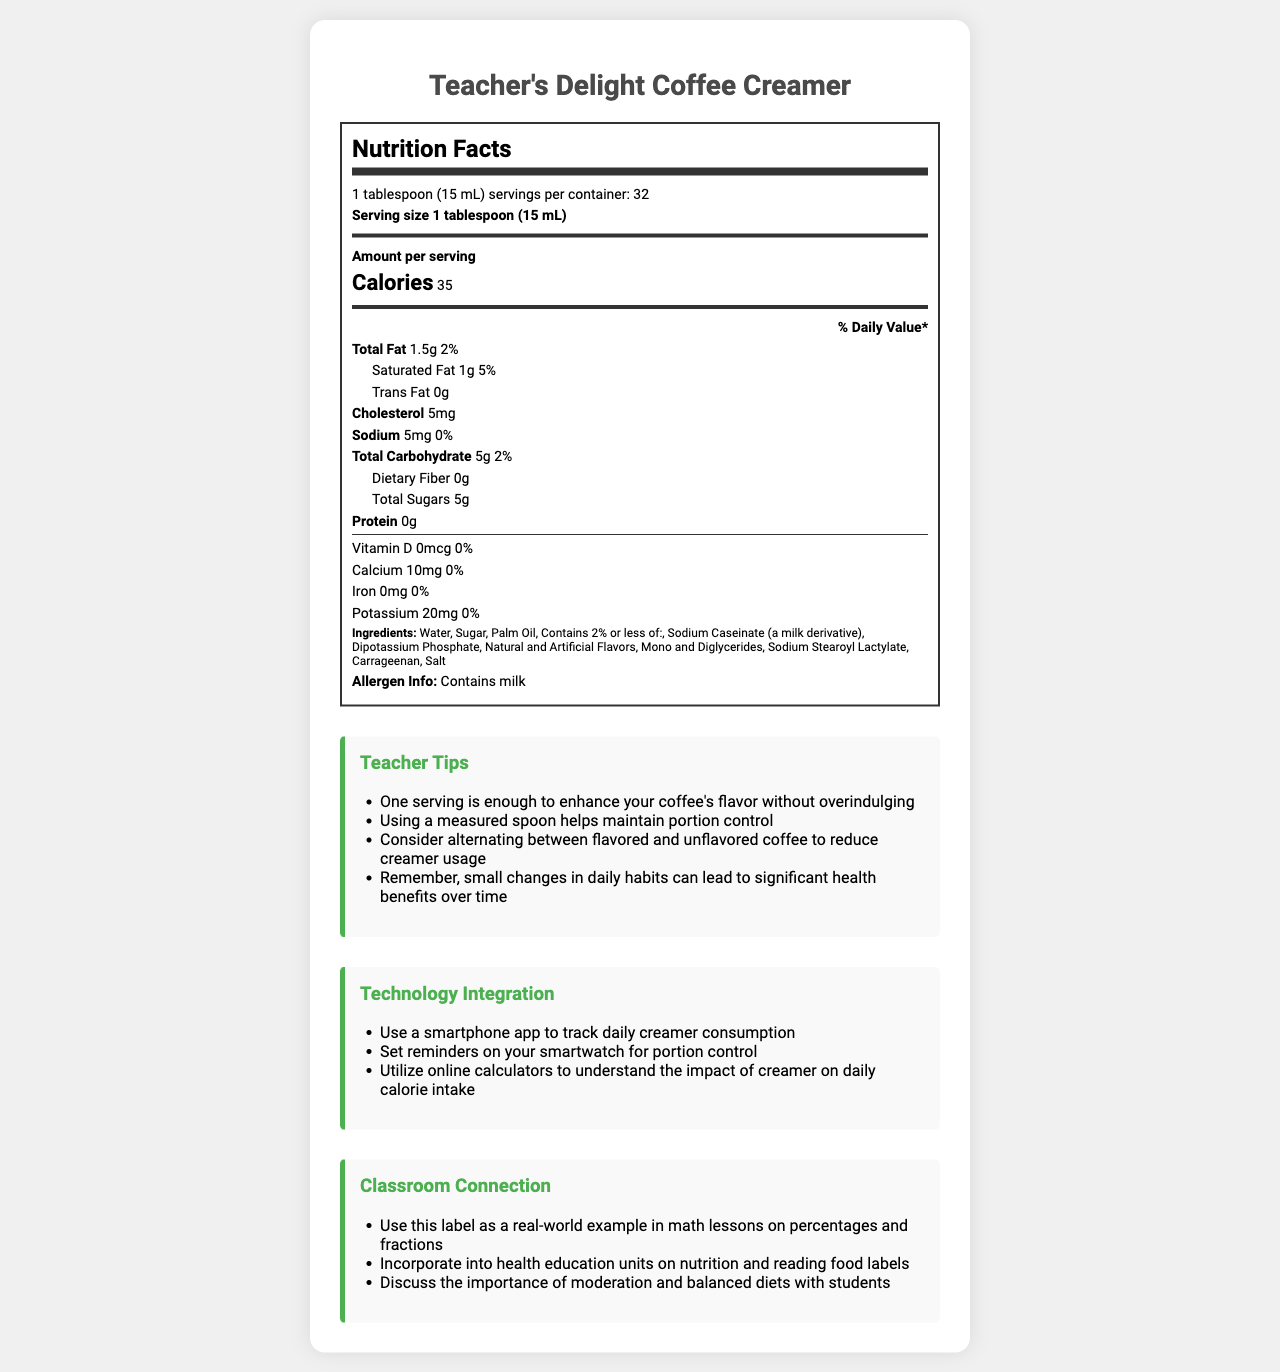what is the serving size? The serving size is clearly stated as "1 tablespoon (15 mL)" at the beginning of the nutrition facts section.
Answer: 1 tablespoon (15 mL) how many calories are in one serving? The document lists the number of calories per serving as "35" right after the serving size information.
Answer: 35 how much total fat does one serving contain? The total fat content per serving is specified as "1.5g" in the nutrition facts.
Answer: 1.5g what percentage of the daily value does the saturated fat in one serving cover? The document shows that saturated fat per serving is "1g," corresponding to 5% of the daily value.
Answer: 5% how much sugar is in one serving? According to the nutrition facts, there are 5g of total sugars in one serving.
Answer: 5g which allergen is present in Teacher's Delight Coffee Creamer? A. Soy B. Nuts C. Milk The allergen information specifically states "Contains milk."
Answer: C. Milk how many servings are there per container? A. 16 B. 32 C. 48 The document states that there are 32 servings per container.
Answer: B. 32 does the product contain any trans fat? The document clearly lists the trans fat content as "0g."
Answer: No can this document be useful in a math lesson? If yes, how? The document mentions that it can be used as a real-world example in math lessons on percentages and fractions.
Answer: Yes what benefit is highlighted by using a measured spoon for portion control? The teacher tips section advises using a measured spoon to help maintain portion control.
Answer: Helps maintain portion control is there any protein in one serving of the creamer? The nutrition facts label shows "Protein 0g," indicating no protein content in one serving.
Answer: No what is the main idea of this document? The document combines a detailed nutrition facts label, practical tips, and educational connections related to Teacher's Delight Coffee Creamer.
Answer: The document provides the nutritional information and serving details of Teacher's Delight Coffee Creamer, with tips for portion control, technology integration for tracking consumption, and classroom connection ideas for educational purposes. how can teachers use technology to help with portion control? The technology integration section lists these tools to help with portion control.
Answer: Use a smartphone app to track daily creamer consumption, set reminders on a smartwatch, and utilize online calculators to understand the impact of creamer on daily calorie intake does the document mention the amount of Vitamin C in the creamer? The document does not provide any information regarding Vitamin C content in the creamer.
Answer: No 